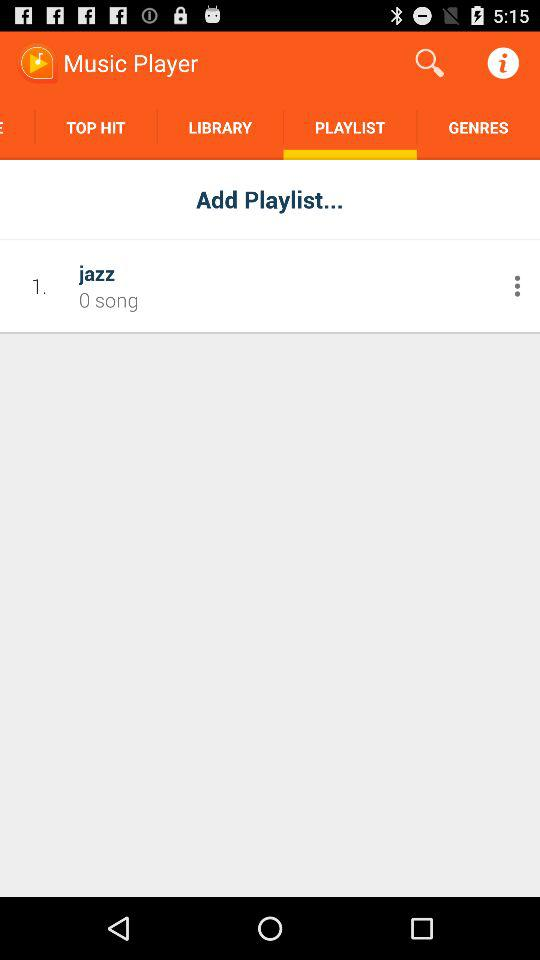What is the app title? The app title is "Music Player". 